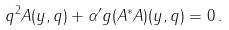<formula> <loc_0><loc_0><loc_500><loc_500>q ^ { 2 } A ( y , q ) + { \alpha ^ { \prime } } g ( A ^ { * } A ) ( y , q ) = 0 \, .</formula> 